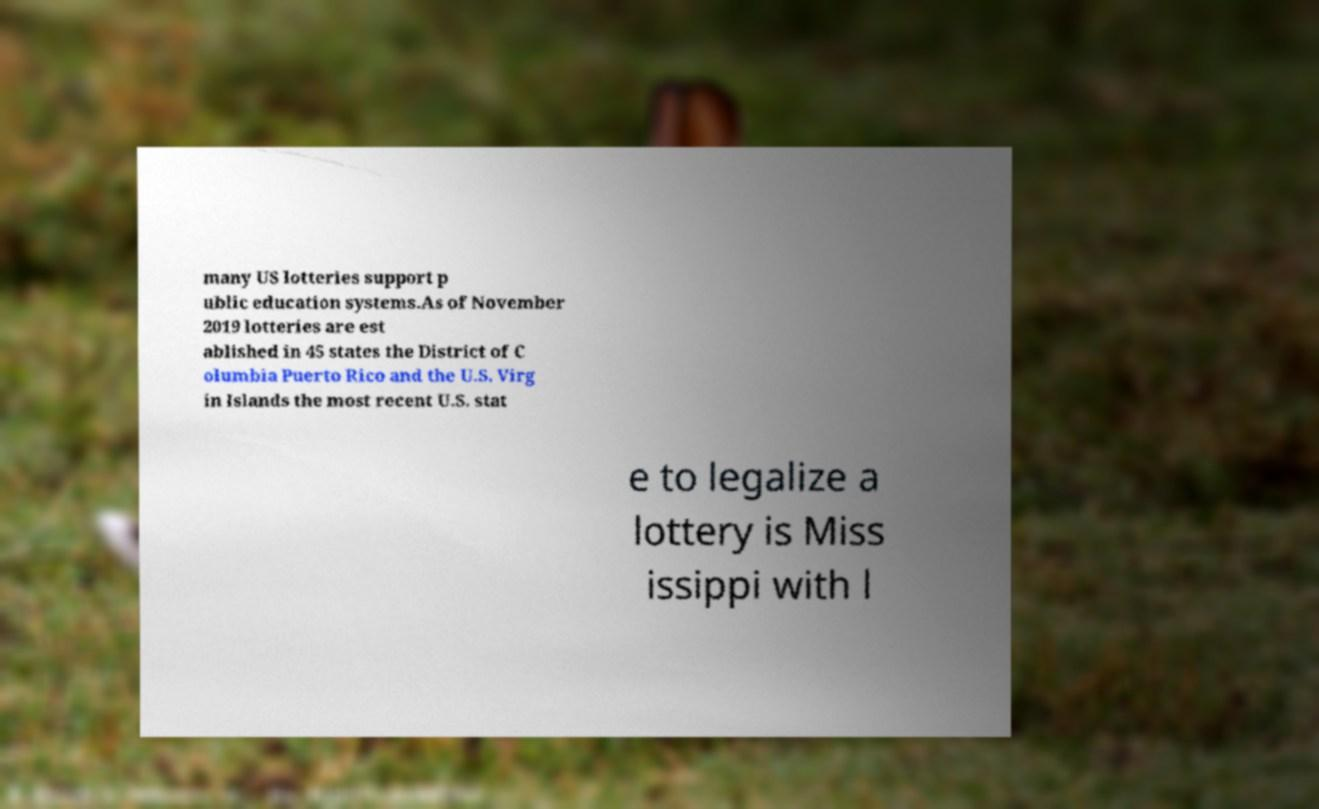Could you assist in decoding the text presented in this image and type it out clearly? many US lotteries support p ublic education systems.As of November 2019 lotteries are est ablished in 45 states the District of C olumbia Puerto Rico and the U.S. Virg in Islands the most recent U.S. stat e to legalize a lottery is Miss issippi with l 